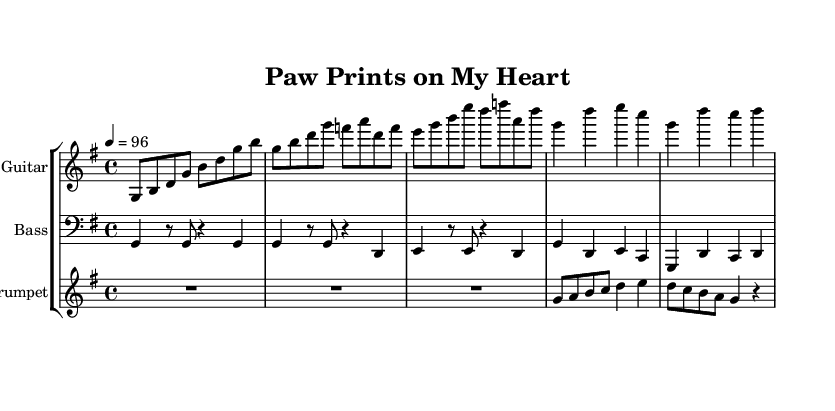What is the key signature of this music? The key signature is G major, which has one sharp (F#). This is indicated at the beginning of the staff, showing the presence of an F sharp, confirming the key of G major.
Answer: G major What is the time signature of this music? The time signature is 4/4, which means there are four beats in each measure, and the quarter note gets one beat. This is indicated at the beginning of the staff.
Answer: 4/4 What is the tempo marking of this piece? The tempo is marked as 96 beats per minute (bpm) as shown in the tempo indication at the beginning of the score. This denotes the speed at which the piece should be played.
Answer: 96 What is the primary instrument featured in the melody? The primary instrument for the melody is the guitar, as it is the first staff listed under the "Guitar" instrument name with the clef and notation corresponding to its part.
Answer: Guitar Identify the type of music genre fused in this piece. This music is a fusion of Reggae and Pop, which combines rhythmic elements from reggae music with the melodic and harmonic structure typical of pop music. The upbeat and fun nature reflects that fusion.
Answer: Reggae-pop How many measures are in the chorus section? The chorus section consists of three measures, which can be identified by counting the measures in the corresponding notation section labeled as the chorus in the score.
Answer: 3 What kind of musical interaction is depicted in the trumpet part during the chorus? The trumpet part has a playful countermelody, which provides a contrasting melodic line that complements the main melody played by the guitar and bass, enhancing the overall texture of the music.
Answer: Playful counter melody 